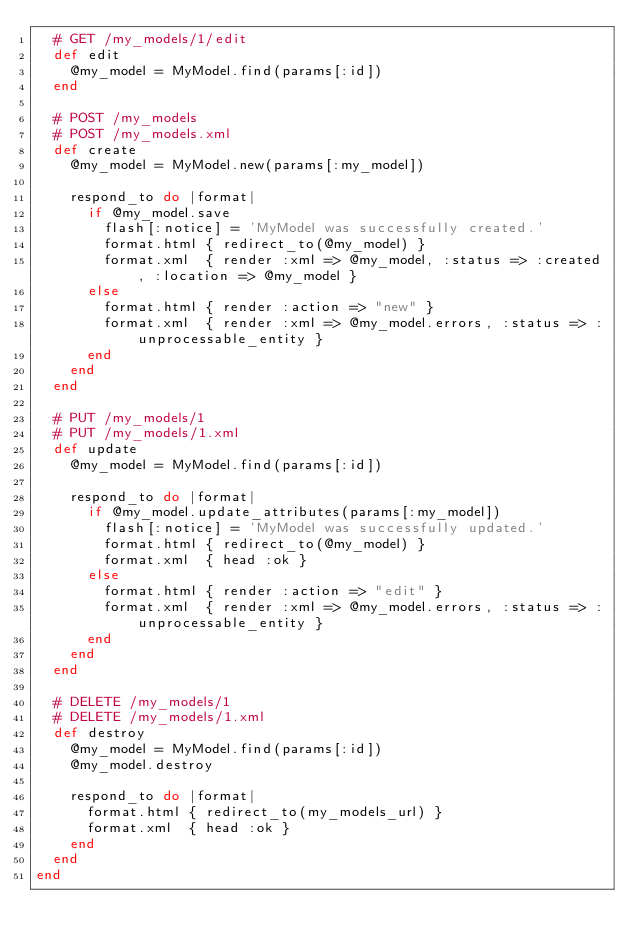Convert code to text. <code><loc_0><loc_0><loc_500><loc_500><_Ruby_>  # GET /my_models/1/edit
  def edit
    @my_model = MyModel.find(params[:id])
  end

  # POST /my_models
  # POST /my_models.xml
  def create
    @my_model = MyModel.new(params[:my_model])

    respond_to do |format|
      if @my_model.save
        flash[:notice] = 'MyModel was successfully created.'
        format.html { redirect_to(@my_model) }
        format.xml  { render :xml => @my_model, :status => :created, :location => @my_model }
      else
        format.html { render :action => "new" }
        format.xml  { render :xml => @my_model.errors, :status => :unprocessable_entity }
      end
    end
  end

  # PUT /my_models/1
  # PUT /my_models/1.xml
  def update
    @my_model = MyModel.find(params[:id])

    respond_to do |format|
      if @my_model.update_attributes(params[:my_model])
        flash[:notice] = 'MyModel was successfully updated.'
        format.html { redirect_to(@my_model) }
        format.xml  { head :ok }
      else
        format.html { render :action => "edit" }
        format.xml  { render :xml => @my_model.errors, :status => :unprocessable_entity }
      end
    end
  end

  # DELETE /my_models/1
  # DELETE /my_models/1.xml
  def destroy
    @my_model = MyModel.find(params[:id])
    @my_model.destroy

    respond_to do |format|
      format.html { redirect_to(my_models_url) }
      format.xml  { head :ok }
    end
  end
end
</code> 